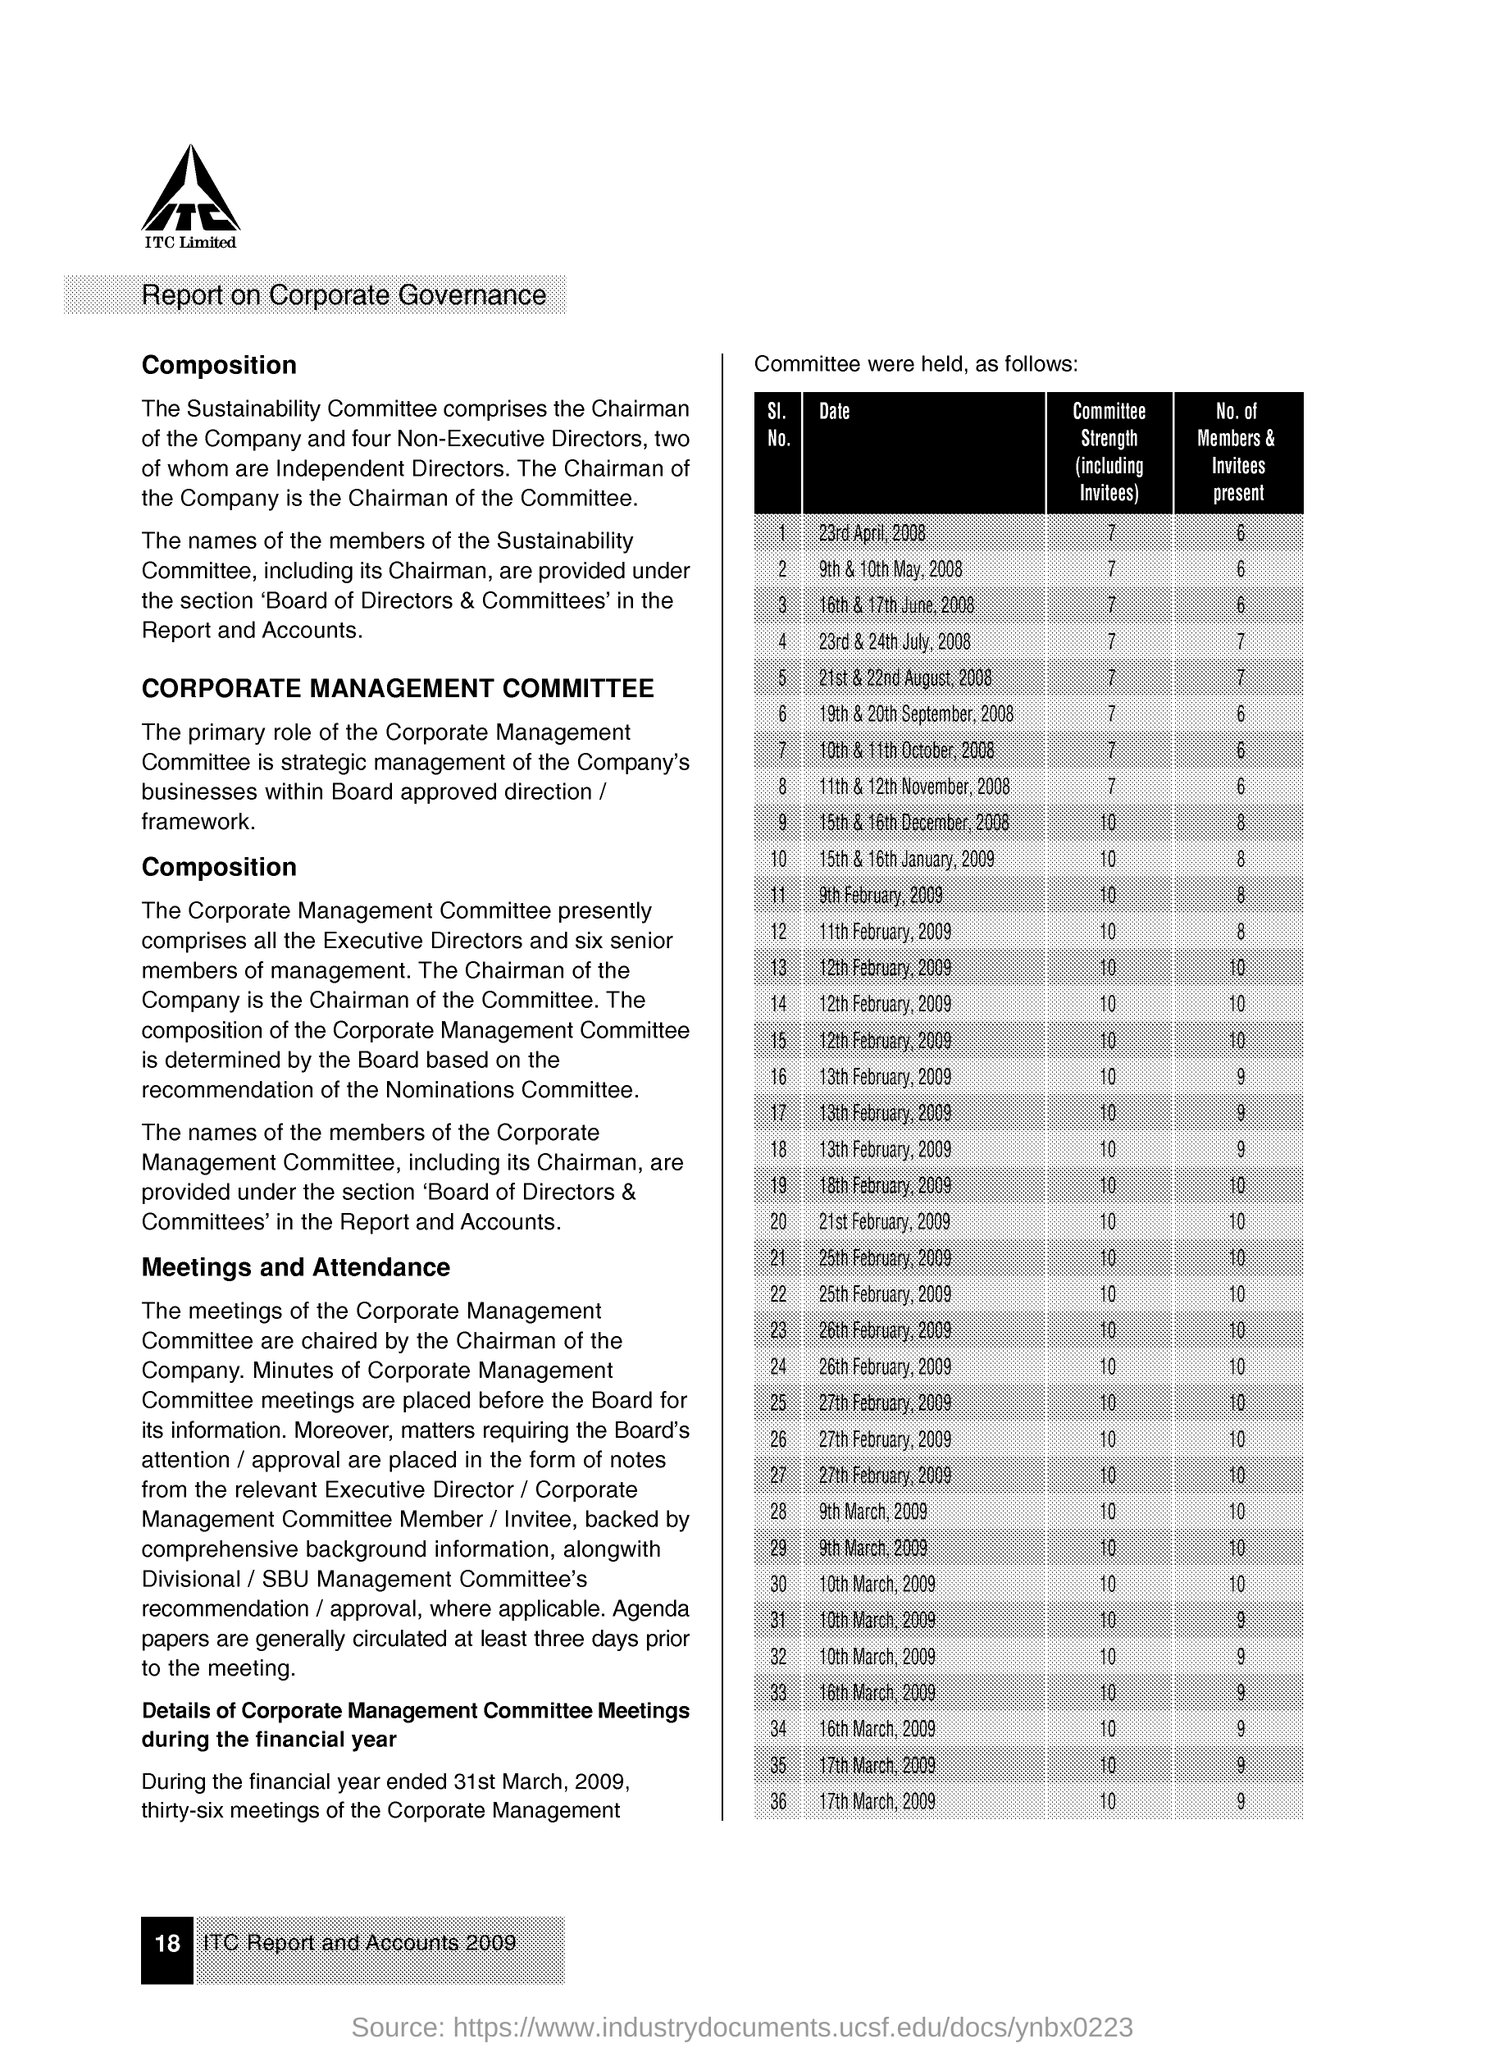What is the Company Name ?
Ensure brevity in your answer.  ITC Limited. 